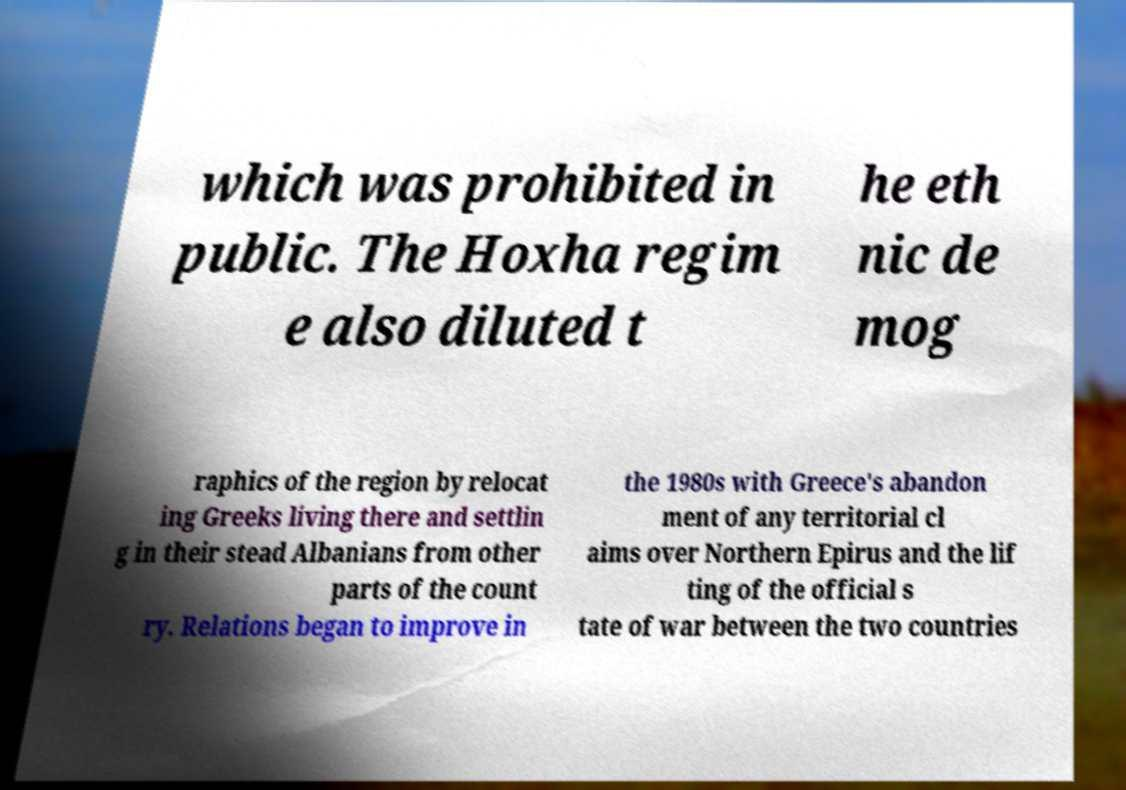What messages or text are displayed in this image? I need them in a readable, typed format. which was prohibited in public. The Hoxha regim e also diluted t he eth nic de mog raphics of the region by relocat ing Greeks living there and settlin g in their stead Albanians from other parts of the count ry. Relations began to improve in the 1980s with Greece's abandon ment of any territorial cl aims over Northern Epirus and the lif ting of the official s tate of war between the two countries 